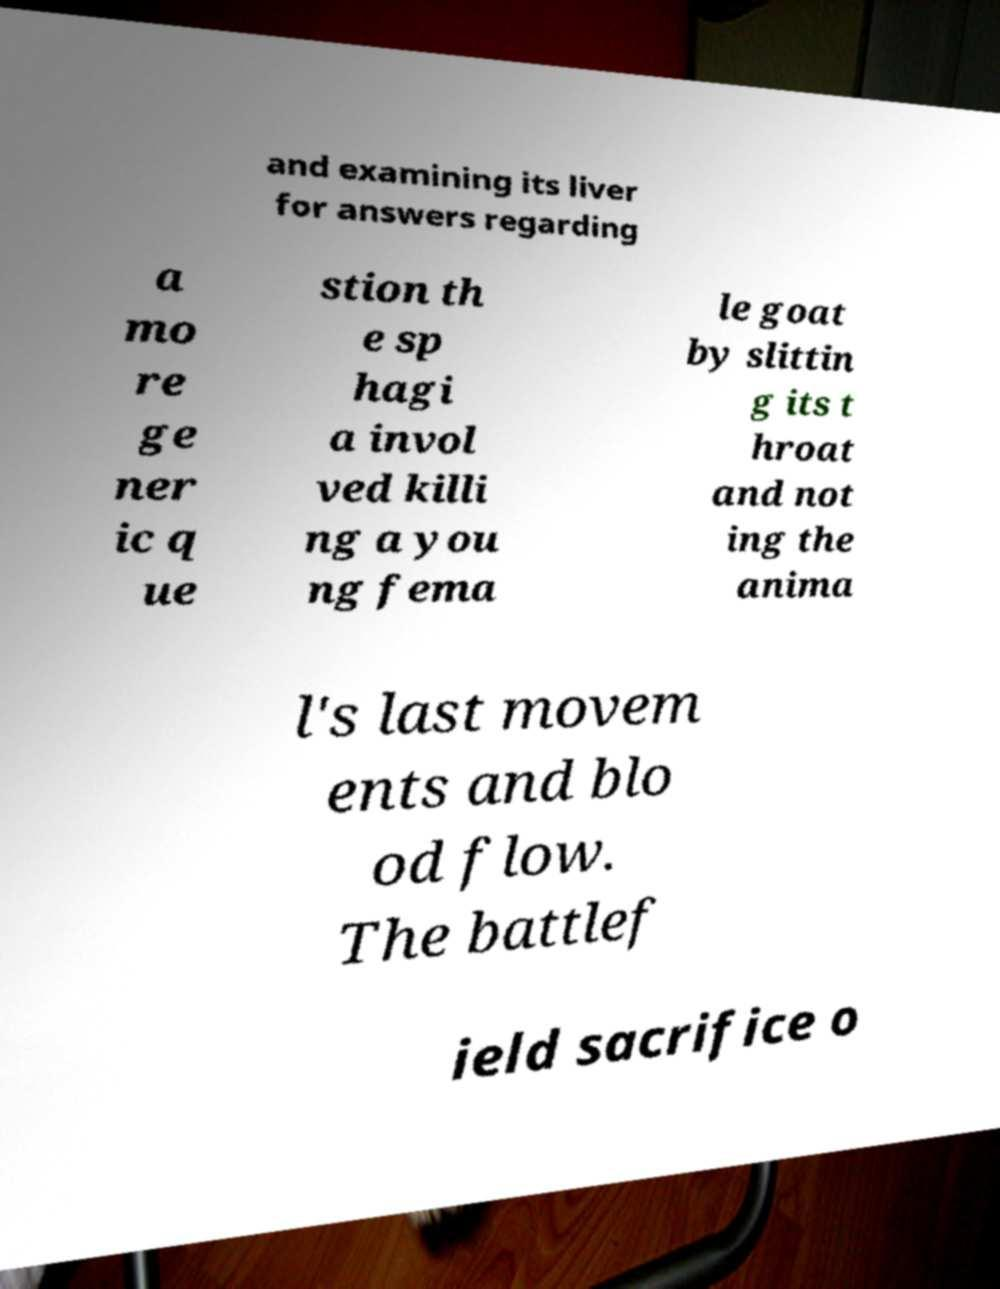I need the written content from this picture converted into text. Can you do that? and examining its liver for answers regarding a mo re ge ner ic q ue stion th e sp hagi a invol ved killi ng a you ng fema le goat by slittin g its t hroat and not ing the anima l's last movem ents and blo od flow. The battlef ield sacrifice o 